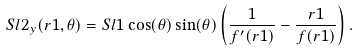Convert formula to latex. <formula><loc_0><loc_0><loc_500><loc_500>S l 2 _ { y } ( r 1 , \theta ) = S l 1 \cos ( \theta ) \sin ( \theta ) \left ( \frac { 1 } { f ^ { \prime } ( r 1 ) } - \frac { r 1 } { f ( r 1 ) } \right ) .</formula> 